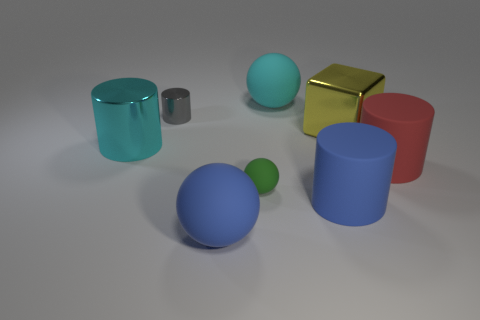Subtract 1 cylinders. How many cylinders are left? 3 Add 2 cyan shiny cylinders. How many objects exist? 10 Subtract all balls. How many objects are left? 5 Subtract 0 green cubes. How many objects are left? 8 Subtract all red matte spheres. Subtract all red rubber objects. How many objects are left? 7 Add 5 tiny matte spheres. How many tiny matte spheres are left? 6 Add 2 big shiny balls. How many big shiny balls exist? 2 